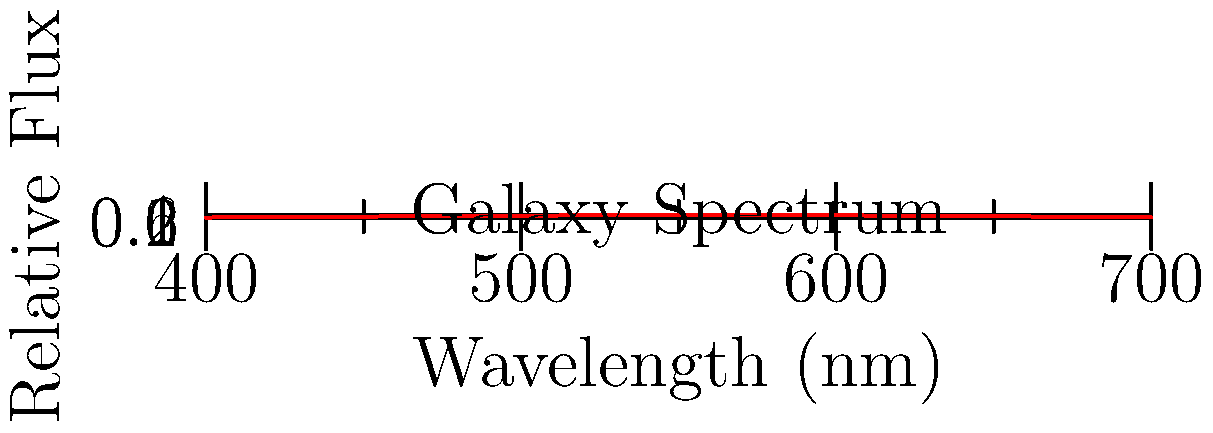Given the spectral data of a distant galaxy as shown in the graph, which machine learning algorithm would be most suitable for identifying spectral features and classifying the galaxy type, and why? To answer this question, we need to consider the characteristics of the spectral data and the requirements of the classification task:

1. The data is continuous and shows a clear pattern (spectral lines and continuum).
2. We need to identify specific features (peaks and troughs) in the spectrum.
3. The goal is to classify the galaxy type based on these features.
4. The dataset likely contains many examples of different galaxy types.

Considering these factors, the most suitable machine learning algorithm would be a Convolutional Neural Network (CNN) for the following reasons:

1. CNNs are excellent at identifying spatial patterns in data, which is crucial for recognizing spectral features.
2. They can automatically learn hierarchical features from the raw spectral data without manual feature engineering.
3. CNNs are robust to small shifts and distortions in the input data, which is important when dealing with redshifted spectra from distant galaxies.
4. They can handle large datasets efficiently, which is typical in astrophysics research.
5. CNNs have shown great success in similar spectral classification tasks in astronomy and other fields.

Other algorithms like Random Forests or Support Vector Machines could also be used, but they would require more manual feature extraction and may not capture the spatial relationships in the spectral data as effectively as CNNs.
Answer: Convolutional Neural Network (CNN) 